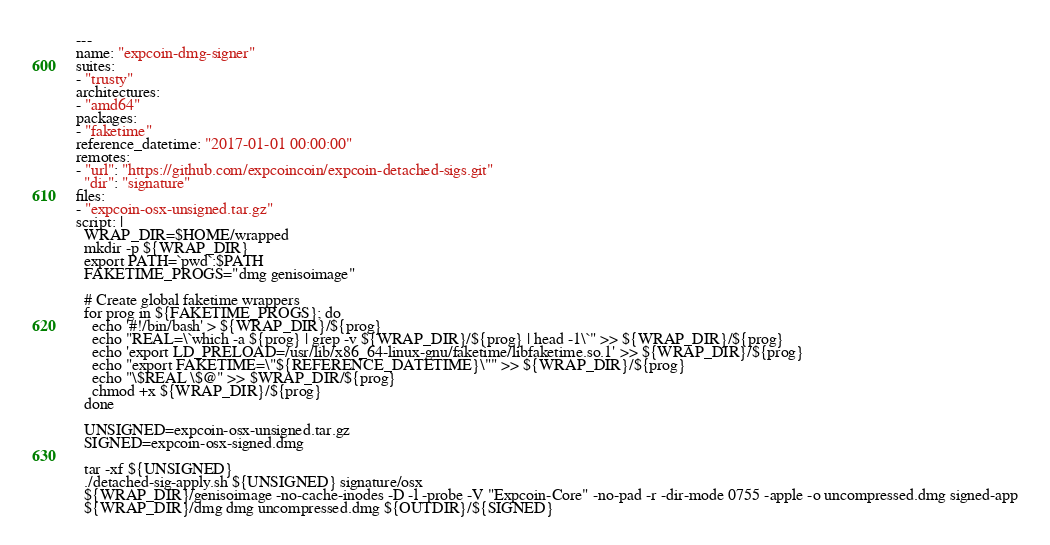<code> <loc_0><loc_0><loc_500><loc_500><_YAML_>---
name: "expcoin-dmg-signer"
suites:
- "trusty"
architectures:
- "amd64"
packages:
- "faketime"
reference_datetime: "2017-01-01 00:00:00"
remotes:
- "url": "https://github.com/expcoincoin/expcoin-detached-sigs.git"
  "dir": "signature"
files:
- "expcoin-osx-unsigned.tar.gz"
script: |
  WRAP_DIR=$HOME/wrapped
  mkdir -p ${WRAP_DIR}
  export PATH=`pwd`:$PATH
  FAKETIME_PROGS="dmg genisoimage"

  # Create global faketime wrappers
  for prog in ${FAKETIME_PROGS}; do
    echo '#!/bin/bash' > ${WRAP_DIR}/${prog}
    echo "REAL=\`which -a ${prog} | grep -v ${WRAP_DIR}/${prog} | head -1\`" >> ${WRAP_DIR}/${prog}
    echo 'export LD_PRELOAD=/usr/lib/x86_64-linux-gnu/faketime/libfaketime.so.1' >> ${WRAP_DIR}/${prog}
    echo "export FAKETIME=\"${REFERENCE_DATETIME}\"" >> ${WRAP_DIR}/${prog}
    echo "\$REAL \$@" >> $WRAP_DIR/${prog}
    chmod +x ${WRAP_DIR}/${prog}
  done

  UNSIGNED=expcoin-osx-unsigned.tar.gz
  SIGNED=expcoin-osx-signed.dmg

  tar -xf ${UNSIGNED}
  ./detached-sig-apply.sh ${UNSIGNED} signature/osx
  ${WRAP_DIR}/genisoimage -no-cache-inodes -D -l -probe -V "Expcoin-Core" -no-pad -r -dir-mode 0755 -apple -o uncompressed.dmg signed-app
  ${WRAP_DIR}/dmg dmg uncompressed.dmg ${OUTDIR}/${SIGNED}
</code> 